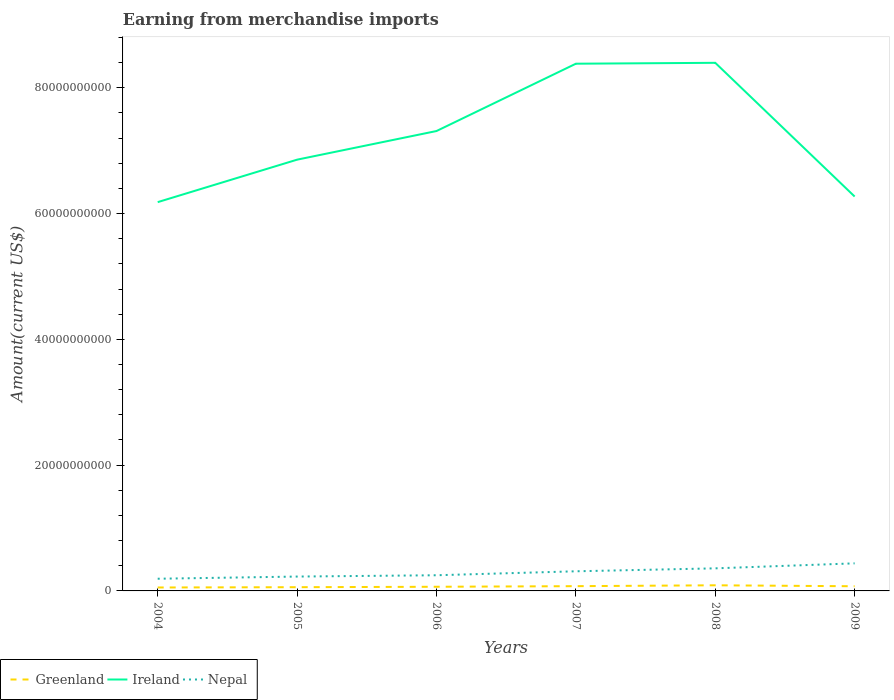How many different coloured lines are there?
Offer a terse response. 3. Does the line corresponding to Greenland intersect with the line corresponding to Ireland?
Give a very brief answer. No. Across all years, what is the maximum amount earned from merchandise imports in Greenland?
Ensure brevity in your answer.  5.46e+08. In which year was the amount earned from merchandise imports in Ireland maximum?
Ensure brevity in your answer.  2004. What is the total amount earned from merchandise imports in Nepal in the graph?
Your response must be concise. -6.30e+08. What is the difference between the highest and the second highest amount earned from merchandise imports in Greenland?
Offer a terse response. 3.49e+08. How many lines are there?
Provide a succinct answer. 3. What is the difference between two consecutive major ticks on the Y-axis?
Your response must be concise. 2.00e+1. Does the graph contain any zero values?
Provide a short and direct response. No. Does the graph contain grids?
Your answer should be compact. No. What is the title of the graph?
Your answer should be very brief. Earning from merchandise imports. Does "Fiji" appear as one of the legend labels in the graph?
Offer a very short reply. No. What is the label or title of the Y-axis?
Give a very brief answer. Amount(current US$). What is the Amount(current US$) of Greenland in 2004?
Provide a short and direct response. 5.46e+08. What is the Amount(current US$) in Ireland in 2004?
Provide a short and direct response. 6.18e+1. What is the Amount(current US$) in Nepal in 2004?
Provide a short and direct response. 1.94e+09. What is the Amount(current US$) of Greenland in 2005?
Your answer should be very brief. 5.92e+08. What is the Amount(current US$) of Ireland in 2005?
Provide a succinct answer. 6.86e+1. What is the Amount(current US$) in Nepal in 2005?
Your response must be concise. 2.28e+09. What is the Amount(current US$) in Greenland in 2006?
Your response must be concise. 6.60e+08. What is the Amount(current US$) in Ireland in 2006?
Give a very brief answer. 7.31e+1. What is the Amount(current US$) in Nepal in 2006?
Give a very brief answer. 2.49e+09. What is the Amount(current US$) of Greenland in 2007?
Offer a terse response. 7.57e+08. What is the Amount(current US$) of Ireland in 2007?
Give a very brief answer. 8.38e+1. What is the Amount(current US$) in Nepal in 2007?
Keep it short and to the point. 3.12e+09. What is the Amount(current US$) in Greenland in 2008?
Offer a terse response. 8.95e+08. What is the Amount(current US$) of Ireland in 2008?
Ensure brevity in your answer.  8.40e+1. What is the Amount(current US$) in Nepal in 2008?
Keep it short and to the point. 3.59e+09. What is the Amount(current US$) of Greenland in 2009?
Provide a short and direct response. 7.42e+08. What is the Amount(current US$) of Ireland in 2009?
Offer a very short reply. 6.27e+1. What is the Amount(current US$) in Nepal in 2009?
Give a very brief answer. 4.38e+09. Across all years, what is the maximum Amount(current US$) of Greenland?
Your answer should be very brief. 8.95e+08. Across all years, what is the maximum Amount(current US$) in Ireland?
Offer a very short reply. 8.40e+1. Across all years, what is the maximum Amount(current US$) in Nepal?
Keep it short and to the point. 4.38e+09. Across all years, what is the minimum Amount(current US$) in Greenland?
Offer a very short reply. 5.46e+08. Across all years, what is the minimum Amount(current US$) of Ireland?
Ensure brevity in your answer.  6.18e+1. Across all years, what is the minimum Amount(current US$) of Nepal?
Ensure brevity in your answer.  1.94e+09. What is the total Amount(current US$) of Greenland in the graph?
Offer a terse response. 4.19e+09. What is the total Amount(current US$) of Ireland in the graph?
Provide a succinct answer. 4.34e+11. What is the total Amount(current US$) of Nepal in the graph?
Your response must be concise. 1.78e+1. What is the difference between the Amount(current US$) of Greenland in 2004 and that in 2005?
Make the answer very short. -4.65e+07. What is the difference between the Amount(current US$) of Ireland in 2004 and that in 2005?
Provide a short and direct response. -6.75e+09. What is the difference between the Amount(current US$) of Nepal in 2004 and that in 2005?
Your answer should be very brief. -3.46e+08. What is the difference between the Amount(current US$) of Greenland in 2004 and that in 2006?
Ensure brevity in your answer.  -1.14e+08. What is the difference between the Amount(current US$) of Ireland in 2004 and that in 2006?
Provide a succinct answer. -1.13e+1. What is the difference between the Amount(current US$) of Nepal in 2004 and that in 2006?
Ensure brevity in your answer.  -5.54e+08. What is the difference between the Amount(current US$) of Greenland in 2004 and that in 2007?
Your answer should be very brief. -2.11e+08. What is the difference between the Amount(current US$) in Ireland in 2004 and that in 2007?
Your answer should be compact. -2.20e+1. What is the difference between the Amount(current US$) of Nepal in 2004 and that in 2007?
Keep it short and to the point. -1.18e+09. What is the difference between the Amount(current US$) in Greenland in 2004 and that in 2008?
Provide a succinct answer. -3.49e+08. What is the difference between the Amount(current US$) of Ireland in 2004 and that in 2008?
Make the answer very short. -2.22e+1. What is the difference between the Amount(current US$) of Nepal in 2004 and that in 2008?
Give a very brief answer. -1.65e+09. What is the difference between the Amount(current US$) of Greenland in 2004 and that in 2009?
Offer a very short reply. -1.96e+08. What is the difference between the Amount(current US$) in Ireland in 2004 and that in 2009?
Make the answer very short. -8.90e+08. What is the difference between the Amount(current US$) of Nepal in 2004 and that in 2009?
Offer a very short reply. -2.45e+09. What is the difference between the Amount(current US$) of Greenland in 2005 and that in 2006?
Give a very brief answer. -6.74e+07. What is the difference between the Amount(current US$) of Ireland in 2005 and that in 2006?
Your response must be concise. -4.55e+09. What is the difference between the Amount(current US$) in Nepal in 2005 and that in 2006?
Your answer should be compact. -2.09e+08. What is the difference between the Amount(current US$) of Greenland in 2005 and that in 2007?
Ensure brevity in your answer.  -1.64e+08. What is the difference between the Amount(current US$) in Ireland in 2005 and that in 2007?
Give a very brief answer. -1.53e+1. What is the difference between the Amount(current US$) of Nepal in 2005 and that in 2007?
Keep it short and to the point. -8.38e+08. What is the difference between the Amount(current US$) of Greenland in 2005 and that in 2008?
Provide a succinct answer. -3.02e+08. What is the difference between the Amount(current US$) of Ireland in 2005 and that in 2008?
Keep it short and to the point. -1.54e+1. What is the difference between the Amount(current US$) in Nepal in 2005 and that in 2008?
Provide a succinct answer. -1.31e+09. What is the difference between the Amount(current US$) of Greenland in 2005 and that in 2009?
Provide a short and direct response. -1.50e+08. What is the difference between the Amount(current US$) in Ireland in 2005 and that in 2009?
Offer a very short reply. 5.86e+09. What is the difference between the Amount(current US$) of Nepal in 2005 and that in 2009?
Your response must be concise. -2.10e+09. What is the difference between the Amount(current US$) in Greenland in 2006 and that in 2007?
Your answer should be compact. -9.70e+07. What is the difference between the Amount(current US$) of Ireland in 2006 and that in 2007?
Offer a very short reply. -1.07e+1. What is the difference between the Amount(current US$) of Nepal in 2006 and that in 2007?
Make the answer very short. -6.30e+08. What is the difference between the Amount(current US$) in Greenland in 2006 and that in 2008?
Provide a short and direct response. -2.35e+08. What is the difference between the Amount(current US$) of Ireland in 2006 and that in 2008?
Offer a very short reply. -1.08e+1. What is the difference between the Amount(current US$) of Nepal in 2006 and that in 2008?
Make the answer very short. -1.10e+09. What is the difference between the Amount(current US$) in Greenland in 2006 and that in 2009?
Offer a very short reply. -8.25e+07. What is the difference between the Amount(current US$) in Ireland in 2006 and that in 2009?
Provide a succinct answer. 1.04e+1. What is the difference between the Amount(current US$) in Nepal in 2006 and that in 2009?
Provide a succinct answer. -1.89e+09. What is the difference between the Amount(current US$) in Greenland in 2007 and that in 2008?
Your response must be concise. -1.38e+08. What is the difference between the Amount(current US$) of Ireland in 2007 and that in 2008?
Offer a terse response. -1.43e+08. What is the difference between the Amount(current US$) of Nepal in 2007 and that in 2008?
Ensure brevity in your answer.  -4.69e+08. What is the difference between the Amount(current US$) in Greenland in 2007 and that in 2009?
Offer a very short reply. 1.45e+07. What is the difference between the Amount(current US$) of Ireland in 2007 and that in 2009?
Ensure brevity in your answer.  2.11e+1. What is the difference between the Amount(current US$) of Nepal in 2007 and that in 2009?
Provide a succinct answer. -1.26e+09. What is the difference between the Amount(current US$) in Greenland in 2008 and that in 2009?
Your response must be concise. 1.52e+08. What is the difference between the Amount(current US$) of Ireland in 2008 and that in 2009?
Provide a short and direct response. 2.13e+1. What is the difference between the Amount(current US$) in Nepal in 2008 and that in 2009?
Your response must be concise. -7.94e+08. What is the difference between the Amount(current US$) in Greenland in 2004 and the Amount(current US$) in Ireland in 2005?
Your answer should be compact. -6.80e+1. What is the difference between the Amount(current US$) in Greenland in 2004 and the Amount(current US$) in Nepal in 2005?
Your answer should be very brief. -1.74e+09. What is the difference between the Amount(current US$) in Ireland in 2004 and the Amount(current US$) in Nepal in 2005?
Offer a very short reply. 5.95e+1. What is the difference between the Amount(current US$) in Greenland in 2004 and the Amount(current US$) in Ireland in 2006?
Offer a very short reply. -7.26e+1. What is the difference between the Amount(current US$) in Greenland in 2004 and the Amount(current US$) in Nepal in 2006?
Ensure brevity in your answer.  -1.95e+09. What is the difference between the Amount(current US$) in Ireland in 2004 and the Amount(current US$) in Nepal in 2006?
Make the answer very short. 5.93e+1. What is the difference between the Amount(current US$) in Greenland in 2004 and the Amount(current US$) in Ireland in 2007?
Offer a terse response. -8.33e+1. What is the difference between the Amount(current US$) of Greenland in 2004 and the Amount(current US$) of Nepal in 2007?
Give a very brief answer. -2.58e+09. What is the difference between the Amount(current US$) of Ireland in 2004 and the Amount(current US$) of Nepal in 2007?
Offer a terse response. 5.87e+1. What is the difference between the Amount(current US$) in Greenland in 2004 and the Amount(current US$) in Ireland in 2008?
Provide a succinct answer. -8.34e+1. What is the difference between the Amount(current US$) of Greenland in 2004 and the Amount(current US$) of Nepal in 2008?
Your response must be concise. -3.04e+09. What is the difference between the Amount(current US$) in Ireland in 2004 and the Amount(current US$) in Nepal in 2008?
Keep it short and to the point. 5.82e+1. What is the difference between the Amount(current US$) in Greenland in 2004 and the Amount(current US$) in Ireland in 2009?
Provide a short and direct response. -6.22e+1. What is the difference between the Amount(current US$) of Greenland in 2004 and the Amount(current US$) of Nepal in 2009?
Make the answer very short. -3.84e+09. What is the difference between the Amount(current US$) of Ireland in 2004 and the Amount(current US$) of Nepal in 2009?
Provide a succinct answer. 5.74e+1. What is the difference between the Amount(current US$) of Greenland in 2005 and the Amount(current US$) of Ireland in 2006?
Offer a terse response. -7.25e+1. What is the difference between the Amount(current US$) in Greenland in 2005 and the Amount(current US$) in Nepal in 2006?
Offer a terse response. -1.90e+09. What is the difference between the Amount(current US$) in Ireland in 2005 and the Amount(current US$) in Nepal in 2006?
Give a very brief answer. 6.61e+1. What is the difference between the Amount(current US$) in Greenland in 2005 and the Amount(current US$) in Ireland in 2007?
Offer a very short reply. -8.32e+1. What is the difference between the Amount(current US$) of Greenland in 2005 and the Amount(current US$) of Nepal in 2007?
Your answer should be very brief. -2.53e+09. What is the difference between the Amount(current US$) in Ireland in 2005 and the Amount(current US$) in Nepal in 2007?
Offer a very short reply. 6.54e+1. What is the difference between the Amount(current US$) of Greenland in 2005 and the Amount(current US$) of Ireland in 2008?
Your response must be concise. -8.34e+1. What is the difference between the Amount(current US$) of Greenland in 2005 and the Amount(current US$) of Nepal in 2008?
Ensure brevity in your answer.  -3.00e+09. What is the difference between the Amount(current US$) in Ireland in 2005 and the Amount(current US$) in Nepal in 2008?
Offer a terse response. 6.50e+1. What is the difference between the Amount(current US$) of Greenland in 2005 and the Amount(current US$) of Ireland in 2009?
Keep it short and to the point. -6.21e+1. What is the difference between the Amount(current US$) in Greenland in 2005 and the Amount(current US$) in Nepal in 2009?
Make the answer very short. -3.79e+09. What is the difference between the Amount(current US$) of Ireland in 2005 and the Amount(current US$) of Nepal in 2009?
Give a very brief answer. 6.42e+1. What is the difference between the Amount(current US$) of Greenland in 2006 and the Amount(current US$) of Ireland in 2007?
Make the answer very short. -8.32e+1. What is the difference between the Amount(current US$) of Greenland in 2006 and the Amount(current US$) of Nepal in 2007?
Provide a short and direct response. -2.46e+09. What is the difference between the Amount(current US$) in Ireland in 2006 and the Amount(current US$) in Nepal in 2007?
Offer a terse response. 7.00e+1. What is the difference between the Amount(current US$) in Greenland in 2006 and the Amount(current US$) in Ireland in 2008?
Provide a succinct answer. -8.33e+1. What is the difference between the Amount(current US$) of Greenland in 2006 and the Amount(current US$) of Nepal in 2008?
Ensure brevity in your answer.  -2.93e+09. What is the difference between the Amount(current US$) of Ireland in 2006 and the Amount(current US$) of Nepal in 2008?
Offer a very short reply. 6.95e+1. What is the difference between the Amount(current US$) in Greenland in 2006 and the Amount(current US$) in Ireland in 2009?
Offer a terse response. -6.20e+1. What is the difference between the Amount(current US$) in Greenland in 2006 and the Amount(current US$) in Nepal in 2009?
Give a very brief answer. -3.72e+09. What is the difference between the Amount(current US$) in Ireland in 2006 and the Amount(current US$) in Nepal in 2009?
Your response must be concise. 6.87e+1. What is the difference between the Amount(current US$) of Greenland in 2007 and the Amount(current US$) of Ireland in 2008?
Your response must be concise. -8.32e+1. What is the difference between the Amount(current US$) in Greenland in 2007 and the Amount(current US$) in Nepal in 2008?
Give a very brief answer. -2.83e+09. What is the difference between the Amount(current US$) in Ireland in 2007 and the Amount(current US$) in Nepal in 2008?
Offer a terse response. 8.02e+1. What is the difference between the Amount(current US$) in Greenland in 2007 and the Amount(current US$) in Ireland in 2009?
Keep it short and to the point. -6.19e+1. What is the difference between the Amount(current US$) in Greenland in 2007 and the Amount(current US$) in Nepal in 2009?
Your answer should be compact. -3.63e+09. What is the difference between the Amount(current US$) in Ireland in 2007 and the Amount(current US$) in Nepal in 2009?
Provide a short and direct response. 7.94e+1. What is the difference between the Amount(current US$) in Greenland in 2008 and the Amount(current US$) in Ireland in 2009?
Provide a short and direct response. -6.18e+1. What is the difference between the Amount(current US$) of Greenland in 2008 and the Amount(current US$) of Nepal in 2009?
Your response must be concise. -3.49e+09. What is the difference between the Amount(current US$) in Ireland in 2008 and the Amount(current US$) in Nepal in 2009?
Offer a terse response. 7.96e+1. What is the average Amount(current US$) of Greenland per year?
Ensure brevity in your answer.  6.99e+08. What is the average Amount(current US$) in Ireland per year?
Offer a terse response. 7.23e+1. What is the average Amount(current US$) of Nepal per year?
Give a very brief answer. 2.97e+09. In the year 2004, what is the difference between the Amount(current US$) of Greenland and Amount(current US$) of Ireland?
Your answer should be very brief. -6.13e+1. In the year 2004, what is the difference between the Amount(current US$) of Greenland and Amount(current US$) of Nepal?
Your response must be concise. -1.39e+09. In the year 2004, what is the difference between the Amount(current US$) in Ireland and Amount(current US$) in Nepal?
Give a very brief answer. 5.99e+1. In the year 2005, what is the difference between the Amount(current US$) of Greenland and Amount(current US$) of Ireland?
Make the answer very short. -6.80e+1. In the year 2005, what is the difference between the Amount(current US$) of Greenland and Amount(current US$) of Nepal?
Your answer should be compact. -1.69e+09. In the year 2005, what is the difference between the Amount(current US$) in Ireland and Amount(current US$) in Nepal?
Ensure brevity in your answer.  6.63e+1. In the year 2006, what is the difference between the Amount(current US$) in Greenland and Amount(current US$) in Ireland?
Offer a terse response. -7.25e+1. In the year 2006, what is the difference between the Amount(current US$) in Greenland and Amount(current US$) in Nepal?
Give a very brief answer. -1.83e+09. In the year 2006, what is the difference between the Amount(current US$) of Ireland and Amount(current US$) of Nepal?
Offer a terse response. 7.06e+1. In the year 2007, what is the difference between the Amount(current US$) of Greenland and Amount(current US$) of Ireland?
Offer a terse response. -8.31e+1. In the year 2007, what is the difference between the Amount(current US$) of Greenland and Amount(current US$) of Nepal?
Give a very brief answer. -2.36e+09. In the year 2007, what is the difference between the Amount(current US$) in Ireland and Amount(current US$) in Nepal?
Offer a terse response. 8.07e+1. In the year 2008, what is the difference between the Amount(current US$) in Greenland and Amount(current US$) in Ireland?
Your response must be concise. -8.31e+1. In the year 2008, what is the difference between the Amount(current US$) of Greenland and Amount(current US$) of Nepal?
Offer a very short reply. -2.70e+09. In the year 2008, what is the difference between the Amount(current US$) of Ireland and Amount(current US$) of Nepal?
Ensure brevity in your answer.  8.04e+1. In the year 2009, what is the difference between the Amount(current US$) of Greenland and Amount(current US$) of Ireland?
Your answer should be compact. -6.20e+1. In the year 2009, what is the difference between the Amount(current US$) of Greenland and Amount(current US$) of Nepal?
Keep it short and to the point. -3.64e+09. In the year 2009, what is the difference between the Amount(current US$) in Ireland and Amount(current US$) in Nepal?
Your response must be concise. 5.83e+1. What is the ratio of the Amount(current US$) in Greenland in 2004 to that in 2005?
Your answer should be very brief. 0.92. What is the ratio of the Amount(current US$) of Ireland in 2004 to that in 2005?
Offer a terse response. 0.9. What is the ratio of the Amount(current US$) of Nepal in 2004 to that in 2005?
Offer a terse response. 0.85. What is the ratio of the Amount(current US$) of Greenland in 2004 to that in 2006?
Offer a very short reply. 0.83. What is the ratio of the Amount(current US$) in Ireland in 2004 to that in 2006?
Make the answer very short. 0.85. What is the ratio of the Amount(current US$) of Nepal in 2004 to that in 2006?
Your answer should be very brief. 0.78. What is the ratio of the Amount(current US$) in Greenland in 2004 to that in 2007?
Your answer should be very brief. 0.72. What is the ratio of the Amount(current US$) in Ireland in 2004 to that in 2007?
Your answer should be very brief. 0.74. What is the ratio of the Amount(current US$) of Nepal in 2004 to that in 2007?
Offer a very short reply. 0.62. What is the ratio of the Amount(current US$) of Greenland in 2004 to that in 2008?
Offer a terse response. 0.61. What is the ratio of the Amount(current US$) of Ireland in 2004 to that in 2008?
Make the answer very short. 0.74. What is the ratio of the Amount(current US$) in Nepal in 2004 to that in 2008?
Provide a short and direct response. 0.54. What is the ratio of the Amount(current US$) of Greenland in 2004 to that in 2009?
Your answer should be compact. 0.74. What is the ratio of the Amount(current US$) in Ireland in 2004 to that in 2009?
Provide a short and direct response. 0.99. What is the ratio of the Amount(current US$) of Nepal in 2004 to that in 2009?
Offer a very short reply. 0.44. What is the ratio of the Amount(current US$) of Greenland in 2005 to that in 2006?
Your answer should be very brief. 0.9. What is the ratio of the Amount(current US$) in Ireland in 2005 to that in 2006?
Offer a terse response. 0.94. What is the ratio of the Amount(current US$) in Nepal in 2005 to that in 2006?
Your answer should be compact. 0.92. What is the ratio of the Amount(current US$) of Greenland in 2005 to that in 2007?
Your response must be concise. 0.78. What is the ratio of the Amount(current US$) in Ireland in 2005 to that in 2007?
Provide a succinct answer. 0.82. What is the ratio of the Amount(current US$) in Nepal in 2005 to that in 2007?
Your response must be concise. 0.73. What is the ratio of the Amount(current US$) in Greenland in 2005 to that in 2008?
Ensure brevity in your answer.  0.66. What is the ratio of the Amount(current US$) in Ireland in 2005 to that in 2008?
Keep it short and to the point. 0.82. What is the ratio of the Amount(current US$) in Nepal in 2005 to that in 2008?
Keep it short and to the point. 0.64. What is the ratio of the Amount(current US$) of Greenland in 2005 to that in 2009?
Provide a succinct answer. 0.8. What is the ratio of the Amount(current US$) in Ireland in 2005 to that in 2009?
Your response must be concise. 1.09. What is the ratio of the Amount(current US$) of Nepal in 2005 to that in 2009?
Keep it short and to the point. 0.52. What is the ratio of the Amount(current US$) in Greenland in 2006 to that in 2007?
Your answer should be compact. 0.87. What is the ratio of the Amount(current US$) of Ireland in 2006 to that in 2007?
Offer a very short reply. 0.87. What is the ratio of the Amount(current US$) of Nepal in 2006 to that in 2007?
Your answer should be compact. 0.8. What is the ratio of the Amount(current US$) in Greenland in 2006 to that in 2008?
Your answer should be very brief. 0.74. What is the ratio of the Amount(current US$) in Ireland in 2006 to that in 2008?
Offer a terse response. 0.87. What is the ratio of the Amount(current US$) of Nepal in 2006 to that in 2008?
Your answer should be very brief. 0.69. What is the ratio of the Amount(current US$) in Ireland in 2006 to that in 2009?
Your answer should be very brief. 1.17. What is the ratio of the Amount(current US$) of Nepal in 2006 to that in 2009?
Keep it short and to the point. 0.57. What is the ratio of the Amount(current US$) of Greenland in 2007 to that in 2008?
Your answer should be compact. 0.85. What is the ratio of the Amount(current US$) in Nepal in 2007 to that in 2008?
Provide a succinct answer. 0.87. What is the ratio of the Amount(current US$) in Greenland in 2007 to that in 2009?
Ensure brevity in your answer.  1.02. What is the ratio of the Amount(current US$) of Ireland in 2007 to that in 2009?
Make the answer very short. 1.34. What is the ratio of the Amount(current US$) in Nepal in 2007 to that in 2009?
Your answer should be very brief. 0.71. What is the ratio of the Amount(current US$) of Greenland in 2008 to that in 2009?
Offer a very short reply. 1.21. What is the ratio of the Amount(current US$) in Ireland in 2008 to that in 2009?
Provide a succinct answer. 1.34. What is the ratio of the Amount(current US$) of Nepal in 2008 to that in 2009?
Your answer should be compact. 0.82. What is the difference between the highest and the second highest Amount(current US$) of Greenland?
Make the answer very short. 1.38e+08. What is the difference between the highest and the second highest Amount(current US$) in Ireland?
Provide a short and direct response. 1.43e+08. What is the difference between the highest and the second highest Amount(current US$) of Nepal?
Ensure brevity in your answer.  7.94e+08. What is the difference between the highest and the lowest Amount(current US$) in Greenland?
Your response must be concise. 3.49e+08. What is the difference between the highest and the lowest Amount(current US$) in Ireland?
Offer a terse response. 2.22e+1. What is the difference between the highest and the lowest Amount(current US$) of Nepal?
Offer a very short reply. 2.45e+09. 